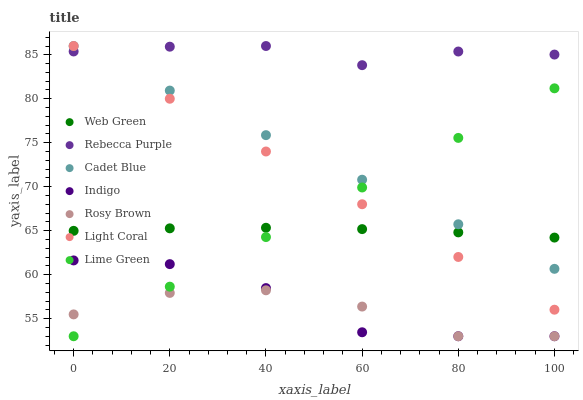Does Rosy Brown have the minimum area under the curve?
Answer yes or no. Yes. Does Rebecca Purple have the maximum area under the curve?
Answer yes or no. Yes. Does Indigo have the minimum area under the curve?
Answer yes or no. No. Does Indigo have the maximum area under the curve?
Answer yes or no. No. Is Lime Green the smoothest?
Answer yes or no. Yes. Is Indigo the roughest?
Answer yes or no. Yes. Is Rosy Brown the smoothest?
Answer yes or no. No. Is Rosy Brown the roughest?
Answer yes or no. No. Does Indigo have the lowest value?
Answer yes or no. Yes. Does Web Green have the lowest value?
Answer yes or no. No. Does Rebecca Purple have the highest value?
Answer yes or no. Yes. Does Indigo have the highest value?
Answer yes or no. No. Is Lime Green less than Rebecca Purple?
Answer yes or no. Yes. Is Rebecca Purple greater than Lime Green?
Answer yes or no. Yes. Does Cadet Blue intersect Web Green?
Answer yes or no. Yes. Is Cadet Blue less than Web Green?
Answer yes or no. No. Is Cadet Blue greater than Web Green?
Answer yes or no. No. Does Lime Green intersect Rebecca Purple?
Answer yes or no. No. 